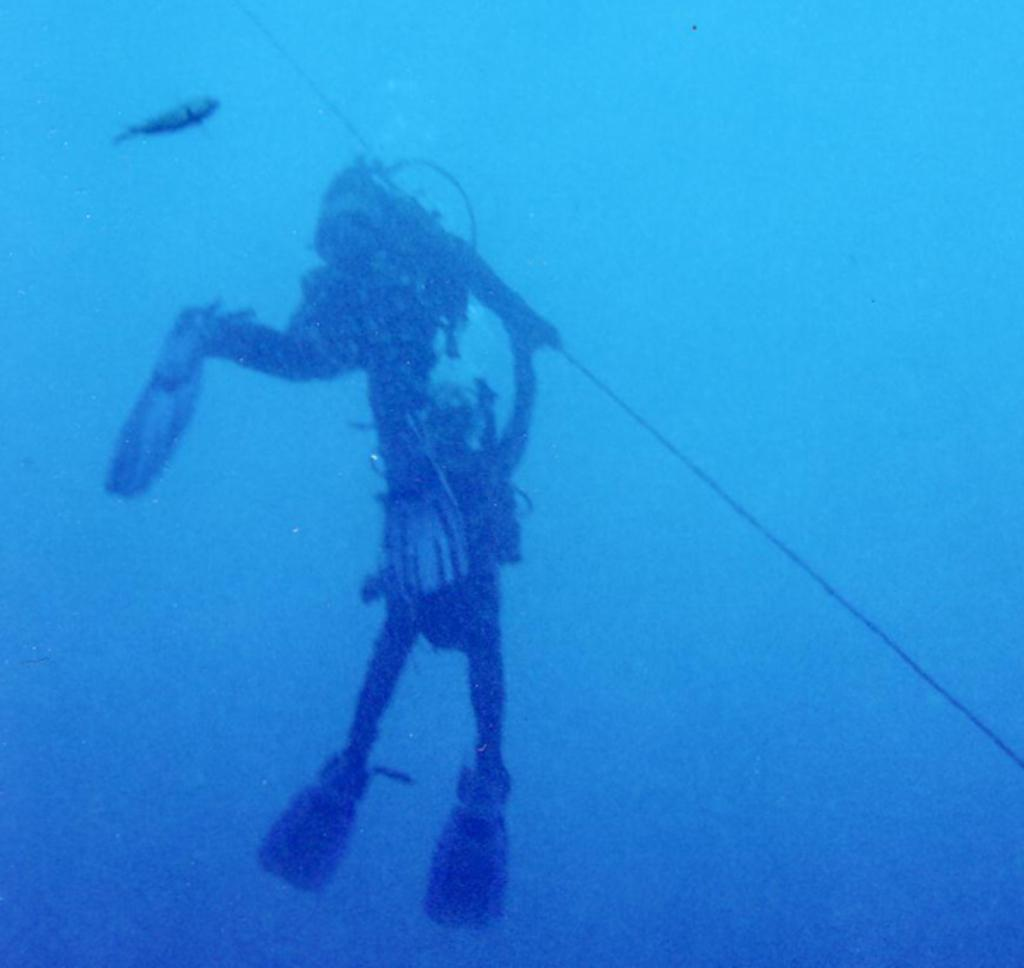What are the two people in the image wearing? The two people in the image are wearing swimming pads. What additional equipment is one person using? One person has an oxygen cylinder attached to their back. Can you describe any aquatic life visible in the image? Yes, there is a fish visible in the water. What time of day is it in the image, considering the afternoon? The time of day is not mentioned or indicated in the image, so it cannot be determined whether it is afternoon or not. 